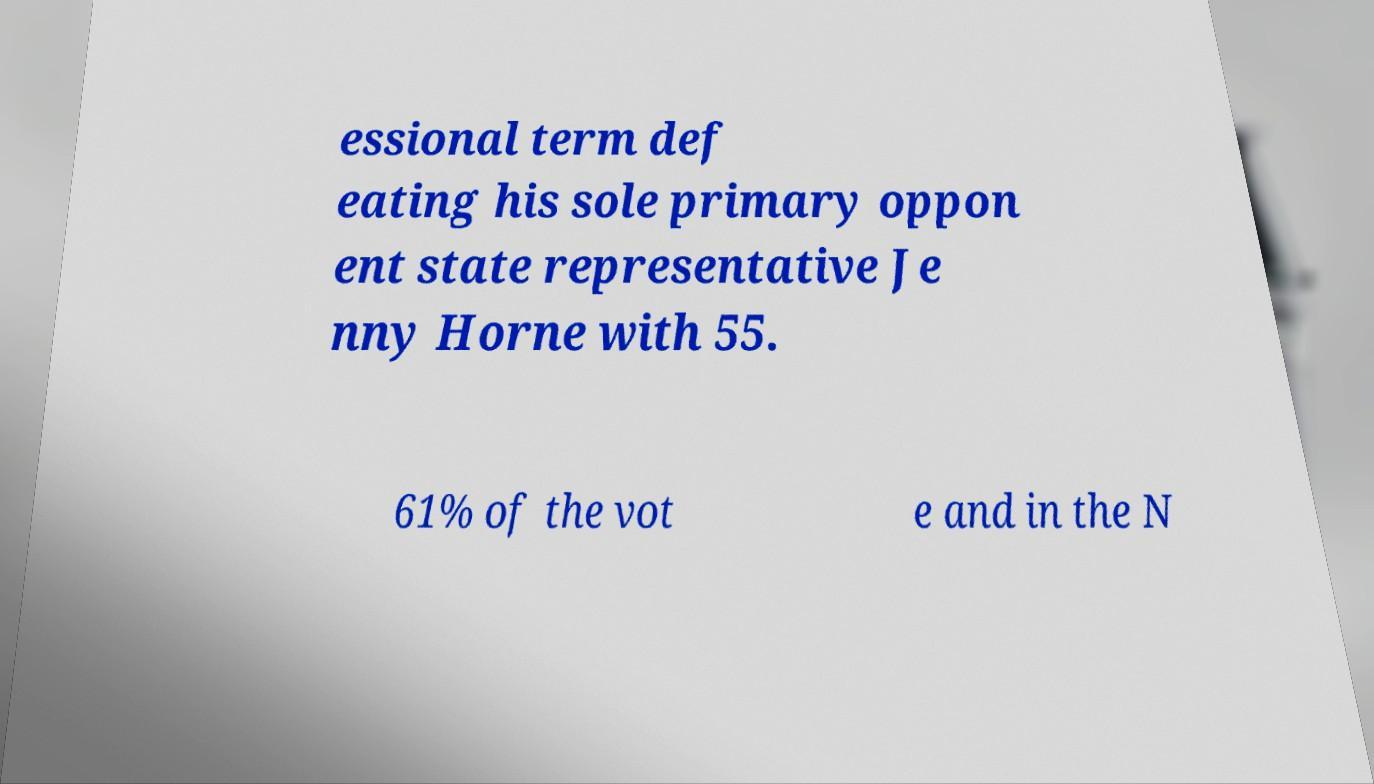There's text embedded in this image that I need extracted. Can you transcribe it verbatim? essional term def eating his sole primary oppon ent state representative Je nny Horne with 55. 61% of the vot e and in the N 